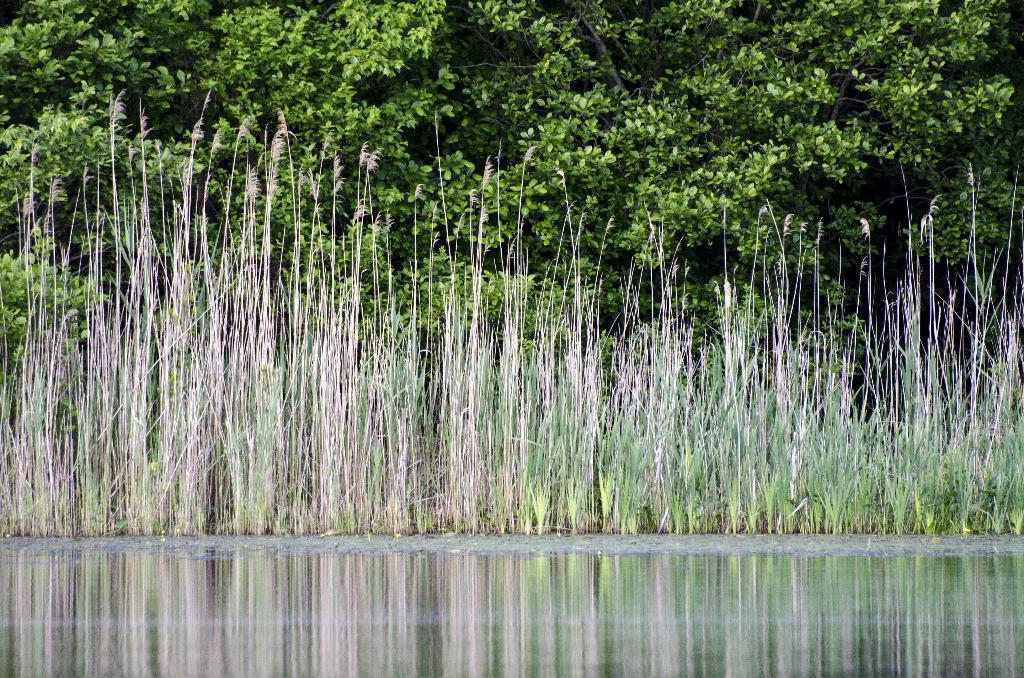How would you summarize this image in a sentence or two? In this picture I can observe water in the bottom of the picture. I can observe some grass in the middle of the picture. In the background there are trees. 